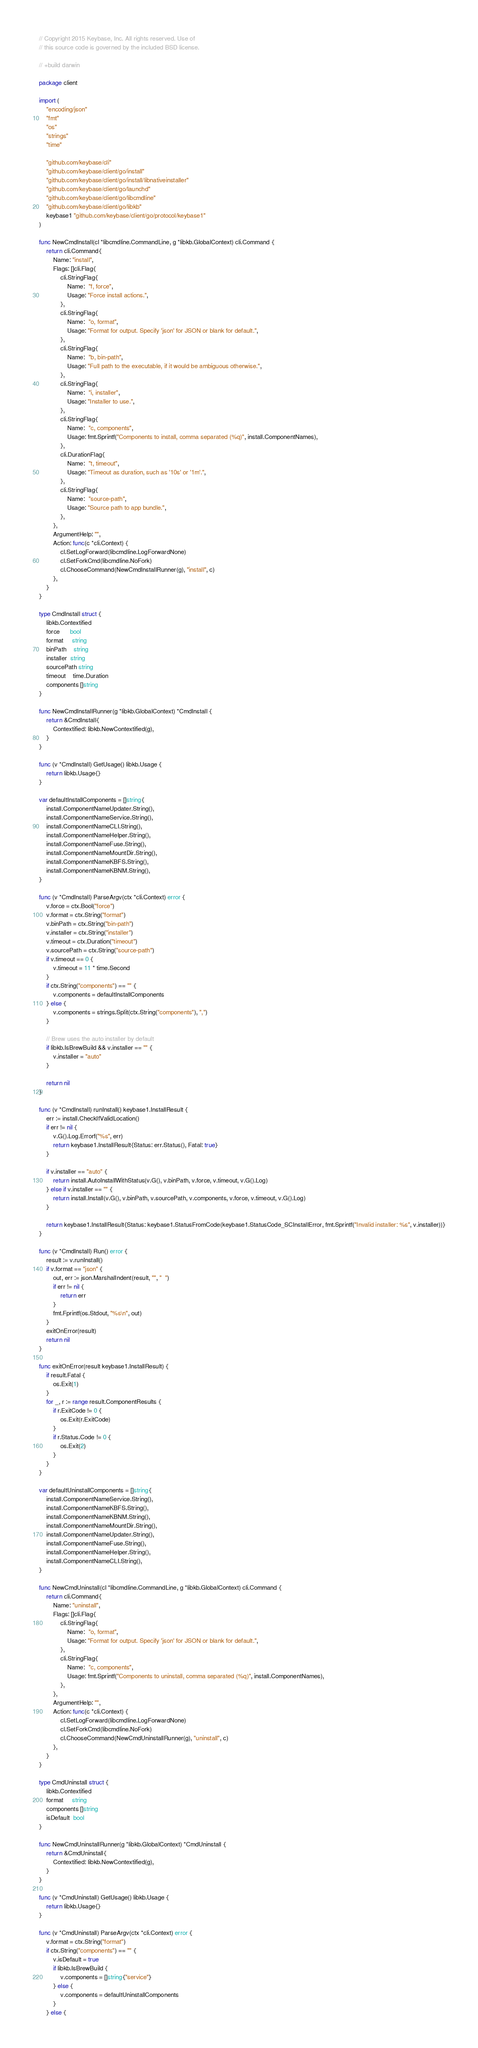Convert code to text. <code><loc_0><loc_0><loc_500><loc_500><_Go_>// Copyright 2015 Keybase, Inc. All rights reserved. Use of
// this source code is governed by the included BSD license.

// +build darwin

package client

import (
	"encoding/json"
	"fmt"
	"os"
	"strings"
	"time"

	"github.com/keybase/cli"
	"github.com/keybase/client/go/install"
	"github.com/keybase/client/go/install/libnativeinstaller"
	"github.com/keybase/client/go/launchd"
	"github.com/keybase/client/go/libcmdline"
	"github.com/keybase/client/go/libkb"
	keybase1 "github.com/keybase/client/go/protocol/keybase1"
)

func NewCmdInstall(cl *libcmdline.CommandLine, g *libkb.GlobalContext) cli.Command {
	return cli.Command{
		Name: "install",
		Flags: []cli.Flag{
			cli.StringFlag{
				Name:  "f, force",
				Usage: "Force install actions.",
			},
			cli.StringFlag{
				Name:  "o, format",
				Usage: "Format for output. Specify 'json' for JSON or blank for default.",
			},
			cli.StringFlag{
				Name:  "b, bin-path",
				Usage: "Full path to the executable, if it would be ambiguous otherwise.",
			},
			cli.StringFlag{
				Name:  "i, installer",
				Usage: "Installer to use.",
			},
			cli.StringFlag{
				Name:  "c, components",
				Usage: fmt.Sprintf("Components to install, comma separated (%q)", install.ComponentNames),
			},
			cli.DurationFlag{
				Name:  "t, timeout",
				Usage: "Timeout as duration, such as '10s' or '1m'.",
			},
			cli.StringFlag{
				Name:  "source-path",
				Usage: "Source path to app bundle.",
			},
		},
		ArgumentHelp: "",
		Action: func(c *cli.Context) {
			cl.SetLogForward(libcmdline.LogForwardNone)
			cl.SetForkCmd(libcmdline.NoFork)
			cl.ChooseCommand(NewCmdInstallRunner(g), "install", c)
		},
	}
}

type CmdInstall struct {
	libkb.Contextified
	force      bool
	format     string
	binPath    string
	installer  string
	sourcePath string
	timeout    time.Duration
	components []string
}

func NewCmdInstallRunner(g *libkb.GlobalContext) *CmdInstall {
	return &CmdInstall{
		Contextified: libkb.NewContextified(g),
	}
}

func (v *CmdInstall) GetUsage() libkb.Usage {
	return libkb.Usage{}
}

var defaultInstallComponents = []string{
	install.ComponentNameUpdater.String(),
	install.ComponentNameService.String(),
	install.ComponentNameCLI.String(),
	install.ComponentNameHelper.String(),
	install.ComponentNameFuse.String(),
	install.ComponentNameMountDir.String(),
	install.ComponentNameKBFS.String(),
	install.ComponentNameKBNM.String(),
}

func (v *CmdInstall) ParseArgv(ctx *cli.Context) error {
	v.force = ctx.Bool("force")
	v.format = ctx.String("format")
	v.binPath = ctx.String("bin-path")
	v.installer = ctx.String("installer")
	v.timeout = ctx.Duration("timeout")
	v.sourcePath = ctx.String("source-path")
	if v.timeout == 0 {
		v.timeout = 11 * time.Second
	}
	if ctx.String("components") == "" {
		v.components = defaultInstallComponents
	} else {
		v.components = strings.Split(ctx.String("components"), ",")
	}

	// Brew uses the auto installer by default
	if libkb.IsBrewBuild && v.installer == "" {
		v.installer = "auto"
	}

	return nil
}

func (v *CmdInstall) runInstall() keybase1.InstallResult {
	err := install.CheckIfValidLocation()
	if err != nil {
		v.G().Log.Errorf("%s", err)
		return keybase1.InstallResult{Status: err.Status(), Fatal: true}
	}

	if v.installer == "auto" {
		return install.AutoInstallWithStatus(v.G(), v.binPath, v.force, v.timeout, v.G().Log)
	} else if v.installer == "" {
		return install.Install(v.G(), v.binPath, v.sourcePath, v.components, v.force, v.timeout, v.G().Log)
	}

	return keybase1.InstallResult{Status: keybase1.StatusFromCode(keybase1.StatusCode_SCInstallError, fmt.Sprintf("Invalid installer: %s", v.installer))}
}

func (v *CmdInstall) Run() error {
	result := v.runInstall()
	if v.format == "json" {
		out, err := json.MarshalIndent(result, "", "  ")
		if err != nil {
			return err
		}
		fmt.Fprintf(os.Stdout, "%s\n", out)
	}
	exitOnError(result)
	return nil
}

func exitOnError(result keybase1.InstallResult) {
	if result.Fatal {
		os.Exit(1)
	}
	for _, r := range result.ComponentResults {
		if r.ExitCode != 0 {
			os.Exit(r.ExitCode)
		}
		if r.Status.Code != 0 {
			os.Exit(2)
		}
	}
}

var defaultUninstallComponents = []string{
	install.ComponentNameService.String(),
	install.ComponentNameKBFS.String(),
	install.ComponentNameKBNM.String(),
	install.ComponentNameMountDir.String(),
	install.ComponentNameUpdater.String(),
	install.ComponentNameFuse.String(),
	install.ComponentNameHelper.String(),
	install.ComponentNameCLI.String(),
}

func NewCmdUninstall(cl *libcmdline.CommandLine, g *libkb.GlobalContext) cli.Command {
	return cli.Command{
		Name: "uninstall",
		Flags: []cli.Flag{
			cli.StringFlag{
				Name:  "o, format",
				Usage: "Format for output. Specify 'json' for JSON or blank for default.",
			},
			cli.StringFlag{
				Name:  "c, components",
				Usage: fmt.Sprintf("Components to uninstall, comma separated (%q)", install.ComponentNames),
			},
		},
		ArgumentHelp: "",
		Action: func(c *cli.Context) {
			cl.SetLogForward(libcmdline.LogForwardNone)
			cl.SetForkCmd(libcmdline.NoFork)
			cl.ChooseCommand(NewCmdUninstallRunner(g), "uninstall", c)
		},
	}
}

type CmdUninstall struct {
	libkb.Contextified
	format     string
	components []string
	isDefault  bool
}

func NewCmdUninstallRunner(g *libkb.GlobalContext) *CmdUninstall {
	return &CmdUninstall{
		Contextified: libkb.NewContextified(g),
	}
}

func (v *CmdUninstall) GetUsage() libkb.Usage {
	return libkb.Usage{}
}

func (v *CmdUninstall) ParseArgv(ctx *cli.Context) error {
	v.format = ctx.String("format")
	if ctx.String("components") == "" {
		v.isDefault = true
		if libkb.IsBrewBuild {
			v.components = []string{"service"}
		} else {
			v.components = defaultUninstallComponents
		}
	} else {</code> 